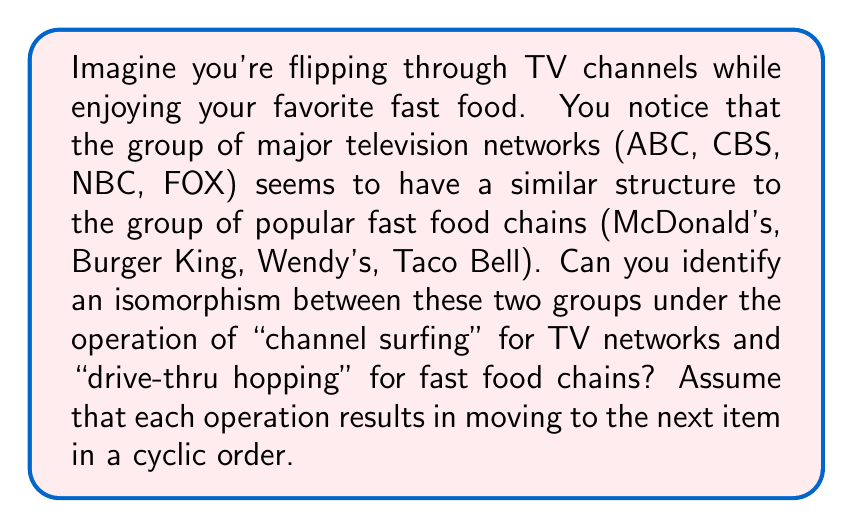Show me your answer to this math problem. To solve this problem, let's approach it step-by-step:

1) First, let's define our groups:
   Group T (TV networks): {ABC, CBS, NBC, FOX}
   Group F (Fast food chains): {McDonald's, Burger King, Wendy's, Taco Bell}

2) The operation for group T is "channel surfing," which we can define as moving to the next channel in a cyclic order:
   ABC → CBS → NBC → FOX → ABC

3) Similarly, the operation for group F is "drive-thru hopping," moving to the next restaurant in a cyclic order:
   McDonald's → Burger King → Wendy's → Taco Bell → McDonald's

4) To establish an isomorphism, we need to find a bijective function $\phi: T \rightarrow F$ that preserves the group operation.

5) Let's define $\phi$ as follows:
   $\phi(\text{ABC}) = \text{McDonald's}$
   $\phi(\text{CBS}) = \text{Burger King}$
   $\phi(\text{NBC}) = \text{Wendy's}$
   $\phi(\text{FOX}) = \text{Taco Bell}$

6) Now, we need to verify that this mapping preserves the group operation. For any elements $a, b \in T$:
   $\phi(a * b) = \phi(a) * \phi(b)$, where $*$ represents the respective group operations.

7) For example:
   $\phi(\text{ABC} * \text{CBS}) = \phi(\text{NBC}) = \text{Wendy's}$
   $\phi(\text{ABC}) * \phi(\text{CBS}) = \text{McDonald's} * \text{Burger King} = \text{Wendy's}$

8) This holds true for all combinations, confirming that $\phi$ is indeed an isomorphism.

Therefore, the groups T and F are isomorphic under the given operations.
Answer: The isomorphism $\phi: T \rightarrow F$ is defined as:
$\phi(\text{ABC}) = \text{McDonald's}$
$\phi(\text{CBS}) = \text{Burger King}$
$\phi(\text{NBC}) = \text{Wendy's}$
$\phi(\text{FOX}) = \text{Taco Bell}$ 